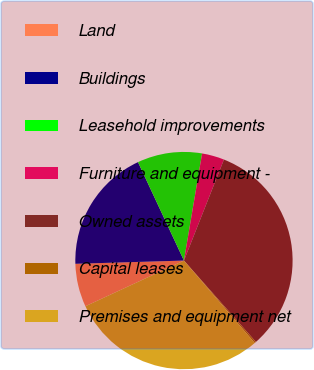Convert chart. <chart><loc_0><loc_0><loc_500><loc_500><pie_chart><fcel>Land<fcel>Buildings<fcel>Leasehold improvements<fcel>Furniture and equipment -<fcel>Owned assets<fcel>Capital leases<fcel>Premises and equipment net<nl><fcel>6.43%<fcel>18.52%<fcel>9.62%<fcel>3.33%<fcel>32.48%<fcel>0.23%<fcel>29.38%<nl></chart> 